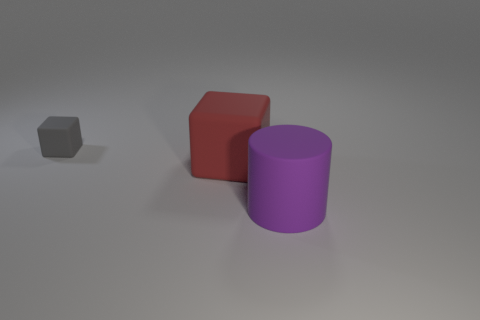Add 3 red matte things. How many objects exist? 6 Subtract all cylinders. How many objects are left? 2 Subtract all purple cylinders. Subtract all red objects. How many objects are left? 1 Add 1 purple objects. How many purple objects are left? 2 Add 2 red cylinders. How many red cylinders exist? 2 Subtract 0 yellow spheres. How many objects are left? 3 